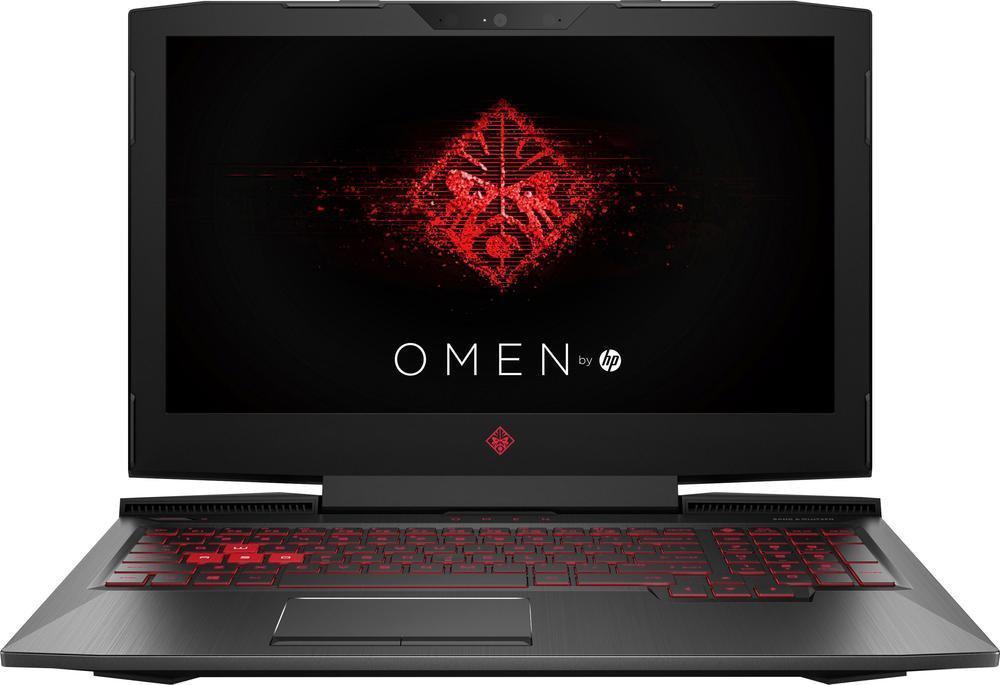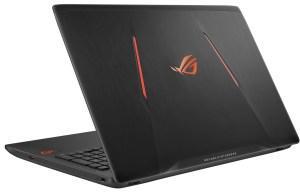The first image is the image on the left, the second image is the image on the right. For the images displayed, is the sentence "Each image contains a single laptop, and one image features a laptop with the screen open to at least a right angle and visible, and the other image shows a laptop facing backward and open at less than 90-degrees." factually correct? Answer yes or no. Yes. The first image is the image on the left, the second image is the image on the right. Given the left and right images, does the statement "The left and right image contains the same number of laptops with one half opened and the other fully opened." hold true? Answer yes or no. Yes. 